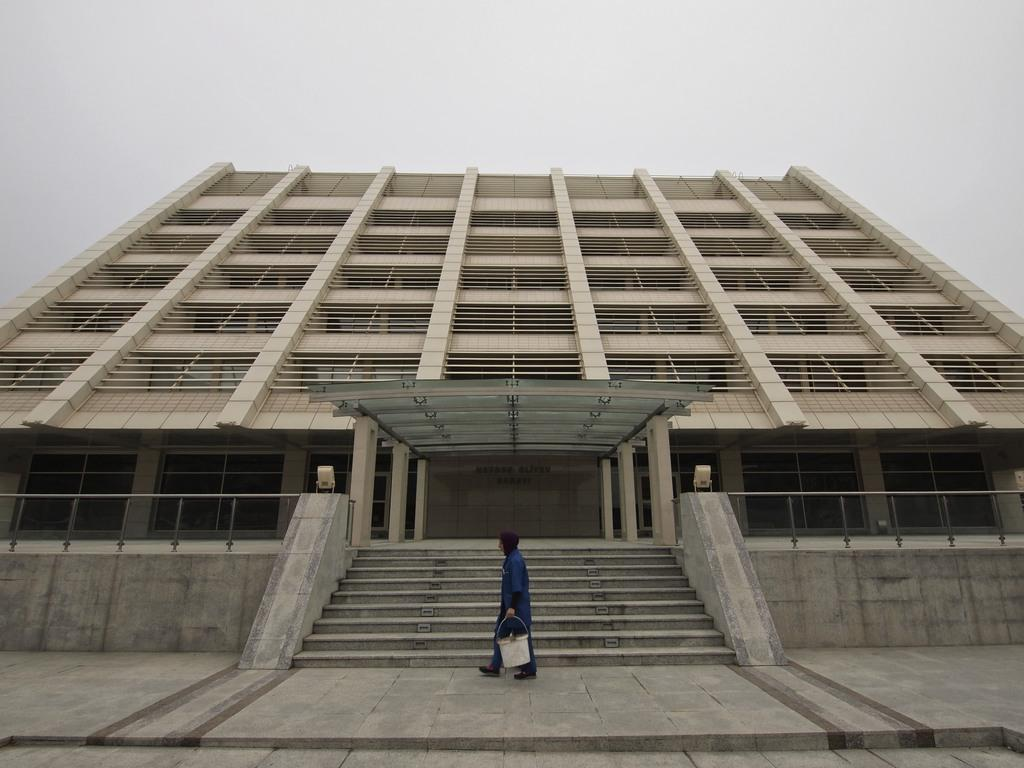What is the main structure in the image? There is a big building in the image. What is happening in front of the building? A person is walking in front of the building. What is the person holding in their hand? The person is holding a bucket in their hand. What architectural feature is present in front of the building? There are steps in front of the building. What can be seen in the background of the image? The sky is visible in the background of the image. How many jellyfish are swimming in the sky in the image? There are no jellyfish present in the image, and the sky is visible in the background. 